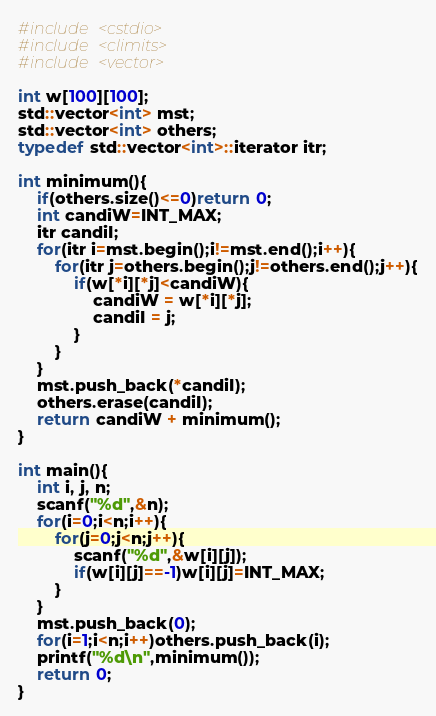<code> <loc_0><loc_0><loc_500><loc_500><_C++_>#include <cstdio>
#include <climits>
#include <vector>

int w[100][100];
std::vector<int> mst;
std::vector<int> others;
typedef std::vector<int>::iterator itr;

int minimum(){
    if(others.size()<=0)return 0;
    int candiW=INT_MAX;
    itr candiI;
    for(itr i=mst.begin();i!=mst.end();i++){
        for(itr j=others.begin();j!=others.end();j++){
            if(w[*i][*j]<candiW){
                candiW = w[*i][*j];
                candiI = j;
            }
        }
    }
    mst.push_back(*candiI);
    others.erase(candiI);
    return candiW + minimum();
}

int main(){
    int i, j, n;
    scanf("%d",&n);
    for(i=0;i<n;i++){
        for(j=0;j<n;j++){
            scanf("%d",&w[i][j]);
            if(w[i][j]==-1)w[i][j]=INT_MAX;
        }
    }
    mst.push_back(0);
    for(i=1;i<n;i++)others.push_back(i);
    printf("%d\n",minimum());
    return 0;
}

</code> 